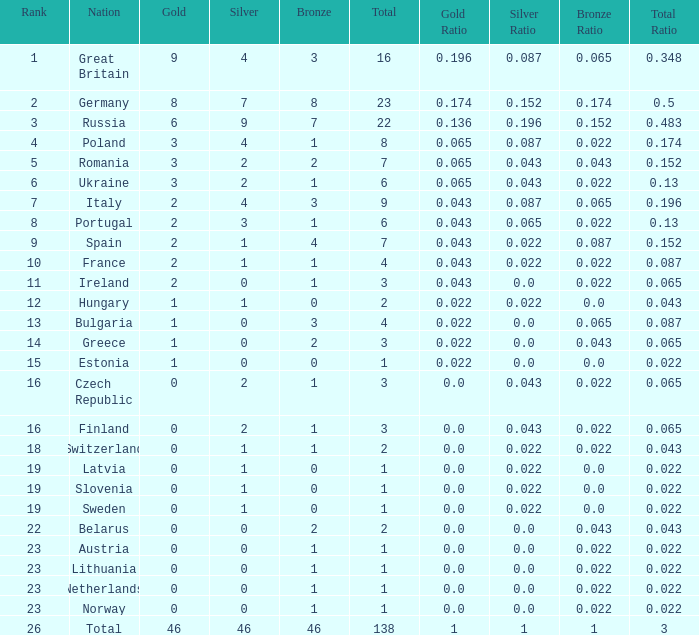What is the most bronze can be when silver is larger than 2, and the nation is germany, and gold is more than 8? None. 